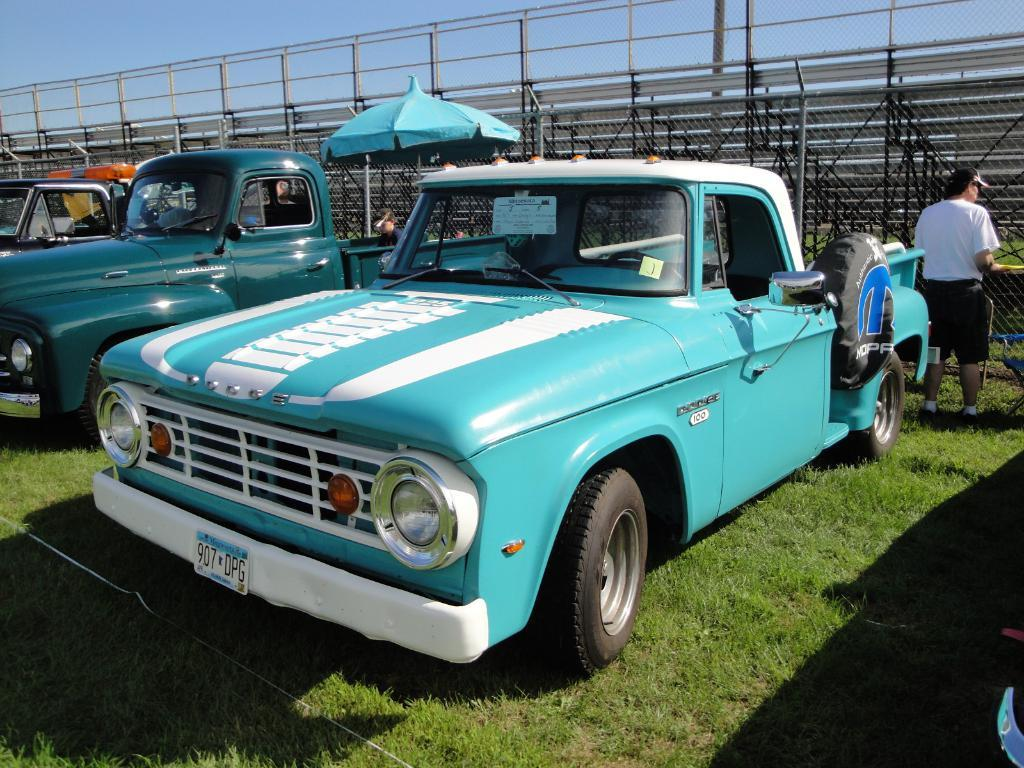What is the main subject of the image? The main subject of the image is a group of vehicles. Can you describe the person in the image? There is a person on the ground in the image. What can be seen in the background of the image? There is a fence in the background of the image. What type of drink is the person holding in the image? There is no drink visible in the image; the person is not holding anything. 